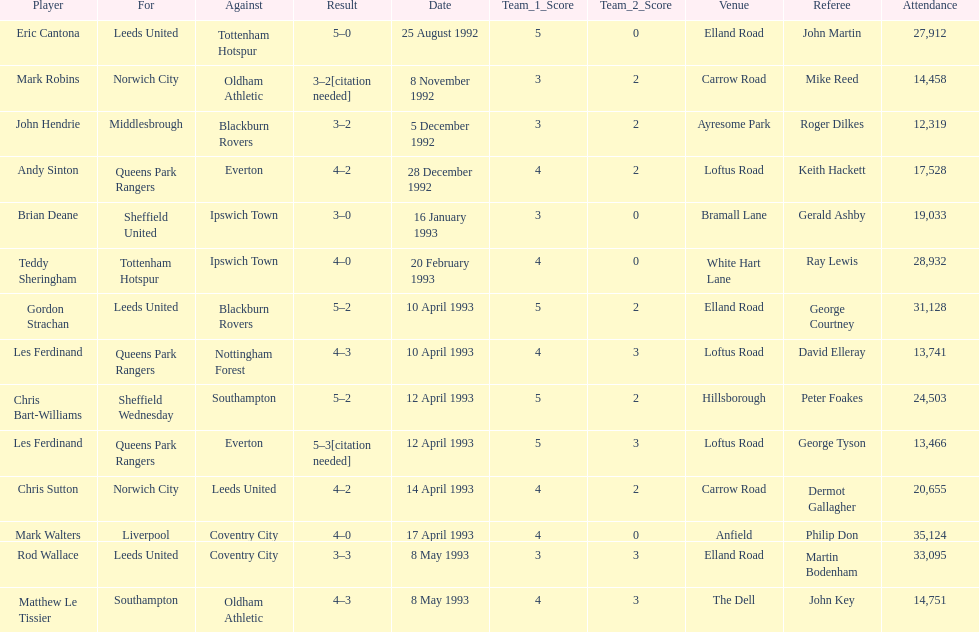How many players were for leeds united? 3. 